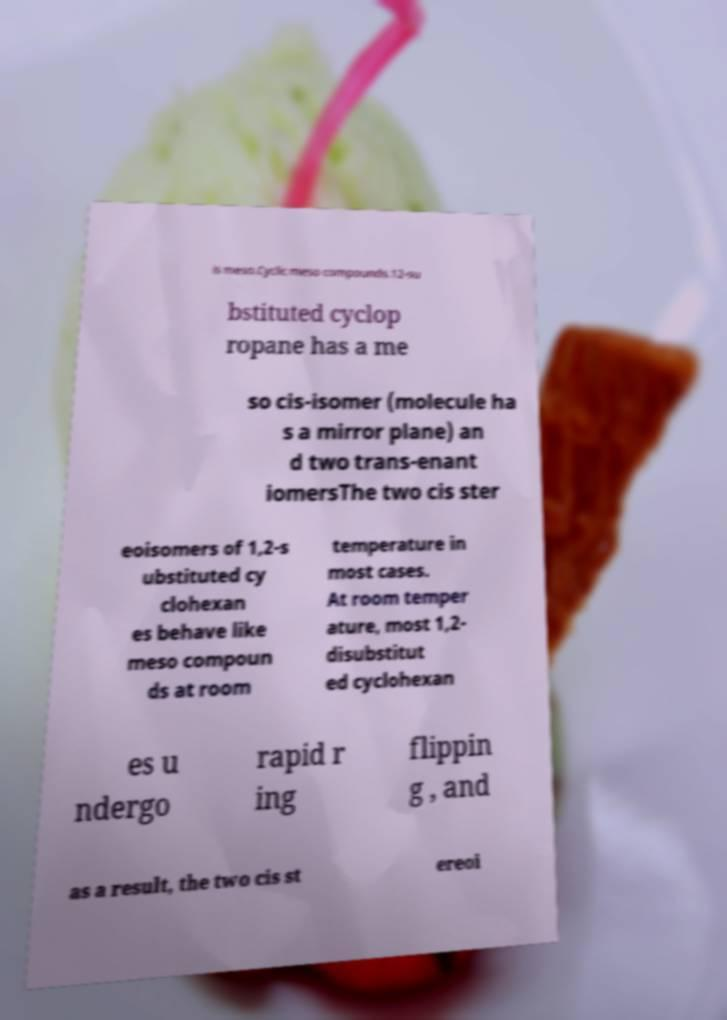Please read and relay the text visible in this image. What does it say? is meso.Cyclic meso compounds.12-su bstituted cyclop ropane has a me so cis-isomer (molecule ha s a mirror plane) an d two trans-enant iomersThe two cis ster eoisomers of 1,2-s ubstituted cy clohexan es behave like meso compoun ds at room temperature in most cases. At room temper ature, most 1,2- disubstitut ed cyclohexan es u ndergo rapid r ing flippin g , and as a result, the two cis st ereoi 